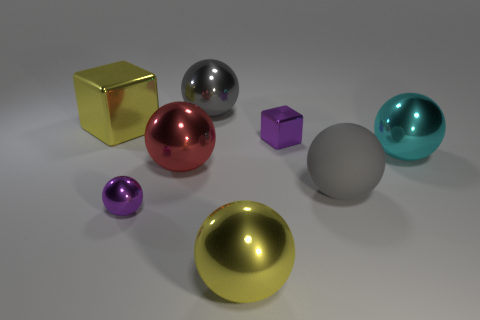Is the material of the tiny cube the same as the large gray sphere right of the gray metal object?
Provide a short and direct response. No. There is a metallic ball that is on the right side of the tiny shiny thing that is behind the large object that is right of the big matte sphere; what color is it?
Your response must be concise. Cyan. Is the number of large yellow shiny blocks greater than the number of big purple matte cylinders?
Provide a succinct answer. Yes. What number of shiny balls are on the right side of the yellow metal sphere and behind the big cyan thing?
Your answer should be very brief. 0. How many red metal balls are behind the big yellow object that is on the right side of the big yellow block?
Make the answer very short. 1. There is a purple metal object that is in front of the cyan ball; is its size the same as the shiny sphere that is behind the big yellow metal cube?
Ensure brevity in your answer.  No. What number of gray spheres are there?
Provide a short and direct response. 2. How many yellow things are the same material as the big cyan thing?
Your answer should be very brief. 2. Are there the same number of cyan balls on the right side of the tiny metallic ball and small purple metallic blocks?
Offer a very short reply. Yes. What material is the small thing that is the same color as the small sphere?
Your answer should be very brief. Metal. 